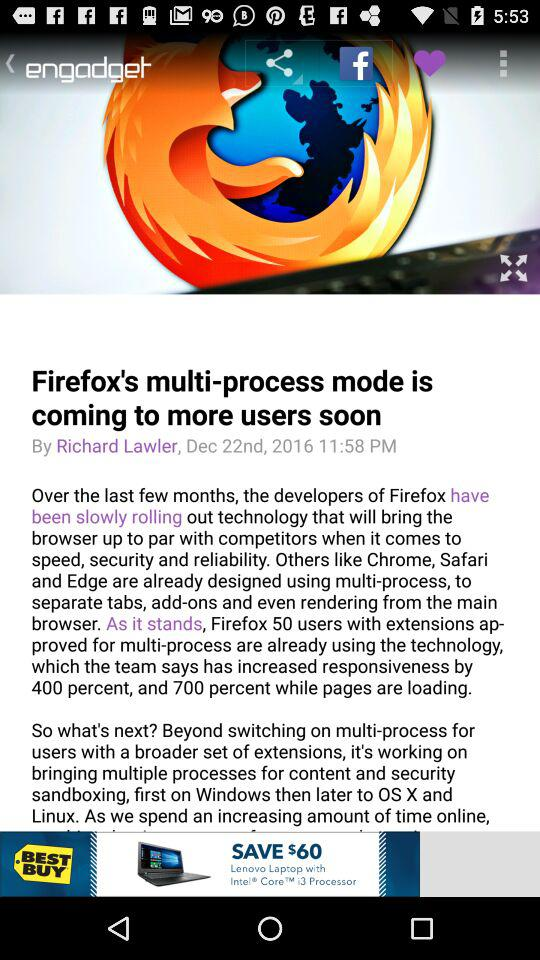How many percent of Sweetgreen's sales were made with cash?
Answer the question using a single word or phrase. 10% 